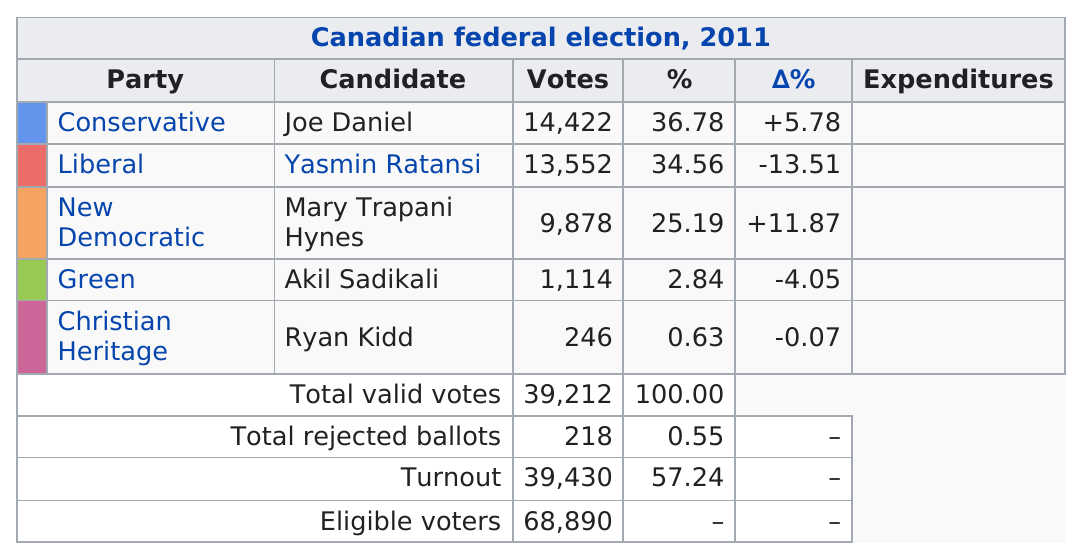Point out several critical features in this image. It is evident that Joe Daniel received the most votes among the candidates. Joe Daniel, Yasmin Ratansi, Mary Trapani Hynes, Akil Sadikali, and Ryan Kidd are the candidates in descending order of their percentage of votes. 